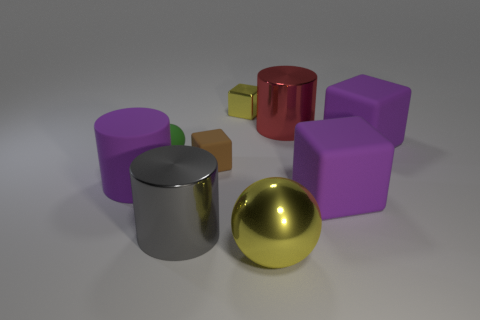What number of brown balls are the same size as the green object?
Your response must be concise. 0. Are there the same number of large balls that are behind the yellow metallic cube and small balls?
Your response must be concise. No. What number of balls are behind the yellow metallic sphere and on the right side of the tiny ball?
Provide a short and direct response. 0. There is a big metallic object behind the tiny rubber cube; is it the same shape as the gray object?
Offer a terse response. Yes. There is a yellow block that is the same size as the green sphere; what is it made of?
Give a very brief answer. Metal. Is the number of yellow balls behind the large metallic ball the same as the number of big metallic things that are right of the shiny cube?
Your response must be concise. No. What number of matte things are to the left of the small block behind the cylinder that is behind the small brown block?
Give a very brief answer. 3. Is the color of the large rubber cylinder the same as the big cylinder that is behind the green sphere?
Make the answer very short. No. What size is the red cylinder that is made of the same material as the small yellow cube?
Give a very brief answer. Large. Are there more yellow objects behind the large rubber cylinder than big purple rubber cubes?
Provide a succinct answer. No. 